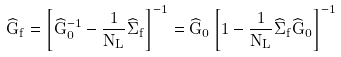<formula> <loc_0><loc_0><loc_500><loc_500>\widehat { G } _ { f } = \left [ \widehat { G } _ { 0 } ^ { - 1 } - \frac { 1 } { N _ { L } } \widehat { \Sigma } _ { f } \right ] ^ { - 1 } = \widehat { G } _ { 0 } \left [ 1 - \frac { 1 } { N _ { L } } \widehat { \Sigma } _ { f } \widehat { G } _ { 0 } \right ] ^ { - 1 }</formula> 